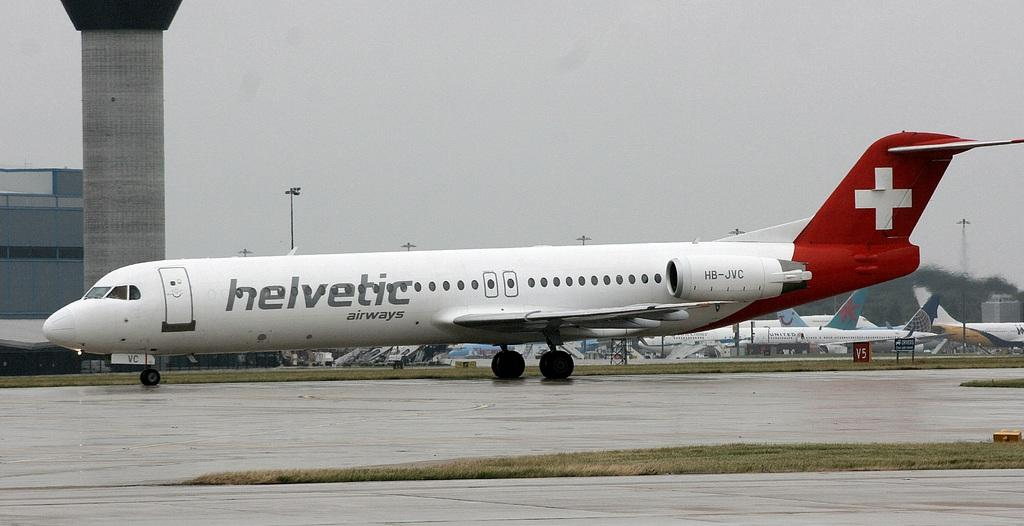<image>
Provide a brief description of the given image. A red and white helvetic airways plane sits on a runway. 